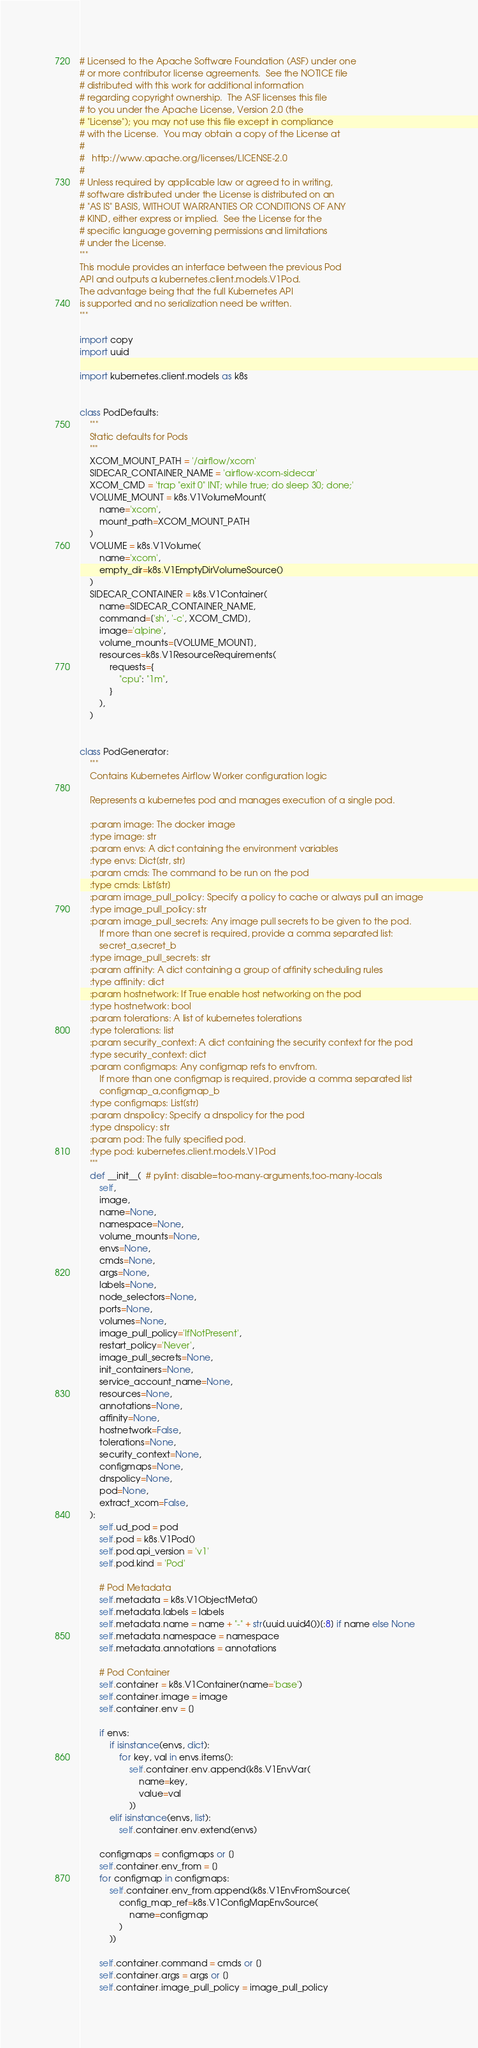<code> <loc_0><loc_0><loc_500><loc_500><_Python_># Licensed to the Apache Software Foundation (ASF) under one
# or more contributor license agreements.  See the NOTICE file
# distributed with this work for additional information
# regarding copyright ownership.  The ASF licenses this file
# to you under the Apache License, Version 2.0 (the
# "License"); you may not use this file except in compliance
# with the License.  You may obtain a copy of the License at
#
#   http://www.apache.org/licenses/LICENSE-2.0
#
# Unless required by applicable law or agreed to in writing,
# software distributed under the License is distributed on an
# "AS IS" BASIS, WITHOUT WARRANTIES OR CONDITIONS OF ANY
# KIND, either express or implied.  See the License for the
# specific language governing permissions and limitations
# under the License.
"""
This module provides an interface between the previous Pod
API and outputs a kubernetes.client.models.V1Pod.
The advantage being that the full Kubernetes API
is supported and no serialization need be written.
"""

import copy
import uuid

import kubernetes.client.models as k8s


class PodDefaults:
    """
    Static defaults for Pods
    """
    XCOM_MOUNT_PATH = '/airflow/xcom'
    SIDECAR_CONTAINER_NAME = 'airflow-xcom-sidecar'
    XCOM_CMD = 'trap "exit 0" INT; while true; do sleep 30; done;'
    VOLUME_MOUNT = k8s.V1VolumeMount(
        name='xcom',
        mount_path=XCOM_MOUNT_PATH
    )
    VOLUME = k8s.V1Volume(
        name='xcom',
        empty_dir=k8s.V1EmptyDirVolumeSource()
    )
    SIDECAR_CONTAINER = k8s.V1Container(
        name=SIDECAR_CONTAINER_NAME,
        command=['sh', '-c', XCOM_CMD],
        image='alpine',
        volume_mounts=[VOLUME_MOUNT],
        resources=k8s.V1ResourceRequirements(
            requests={
                "cpu": "1m",
            }
        ),
    )


class PodGenerator:
    """
    Contains Kubernetes Airflow Worker configuration logic

    Represents a kubernetes pod and manages execution of a single pod.

    :param image: The docker image
    :type image: str
    :param envs: A dict containing the environment variables
    :type envs: Dict[str, str]
    :param cmds: The command to be run on the pod
    :type cmds: List[str]
    :param image_pull_policy: Specify a policy to cache or always pull an image
    :type image_pull_policy: str
    :param image_pull_secrets: Any image pull secrets to be given to the pod.
        If more than one secret is required, provide a comma separated list:
        secret_a,secret_b
    :type image_pull_secrets: str
    :param affinity: A dict containing a group of affinity scheduling rules
    :type affinity: dict
    :param hostnetwork: If True enable host networking on the pod
    :type hostnetwork: bool
    :param tolerations: A list of kubernetes tolerations
    :type tolerations: list
    :param security_context: A dict containing the security context for the pod
    :type security_context: dict
    :param configmaps: Any configmap refs to envfrom.
        If more than one configmap is required, provide a comma separated list
        configmap_a,configmap_b
    :type configmaps: List[str]
    :param dnspolicy: Specify a dnspolicy for the pod
    :type dnspolicy: str
    :param pod: The fully specified pod.
    :type pod: kubernetes.client.models.V1Pod
    """
    def __init__(  # pylint: disable=too-many-arguments,too-many-locals
        self,
        image,
        name=None,
        namespace=None,
        volume_mounts=None,
        envs=None,
        cmds=None,
        args=None,
        labels=None,
        node_selectors=None,
        ports=None,
        volumes=None,
        image_pull_policy='IfNotPresent',
        restart_policy='Never',
        image_pull_secrets=None,
        init_containers=None,
        service_account_name=None,
        resources=None,
        annotations=None,
        affinity=None,
        hostnetwork=False,
        tolerations=None,
        security_context=None,
        configmaps=None,
        dnspolicy=None,
        pod=None,
        extract_xcom=False,
    ):
        self.ud_pod = pod
        self.pod = k8s.V1Pod()
        self.pod.api_version = 'v1'
        self.pod.kind = 'Pod'

        # Pod Metadata
        self.metadata = k8s.V1ObjectMeta()
        self.metadata.labels = labels
        self.metadata.name = name + "-" + str(uuid.uuid4())[:8] if name else None
        self.metadata.namespace = namespace
        self.metadata.annotations = annotations

        # Pod Container
        self.container = k8s.V1Container(name='base')
        self.container.image = image
        self.container.env = []

        if envs:
            if isinstance(envs, dict):
                for key, val in envs.items():
                    self.container.env.append(k8s.V1EnvVar(
                        name=key,
                        value=val
                    ))
            elif isinstance(envs, list):
                self.container.env.extend(envs)

        configmaps = configmaps or []
        self.container.env_from = []
        for configmap in configmaps:
            self.container.env_from.append(k8s.V1EnvFromSource(
                config_map_ref=k8s.V1ConfigMapEnvSource(
                    name=configmap
                )
            ))

        self.container.command = cmds or []
        self.container.args = args or []
        self.container.image_pull_policy = image_pull_policy</code> 